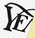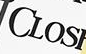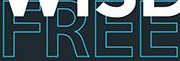Read the text from these images in sequence, separated by a semicolon. YE; CLOS; FREE 